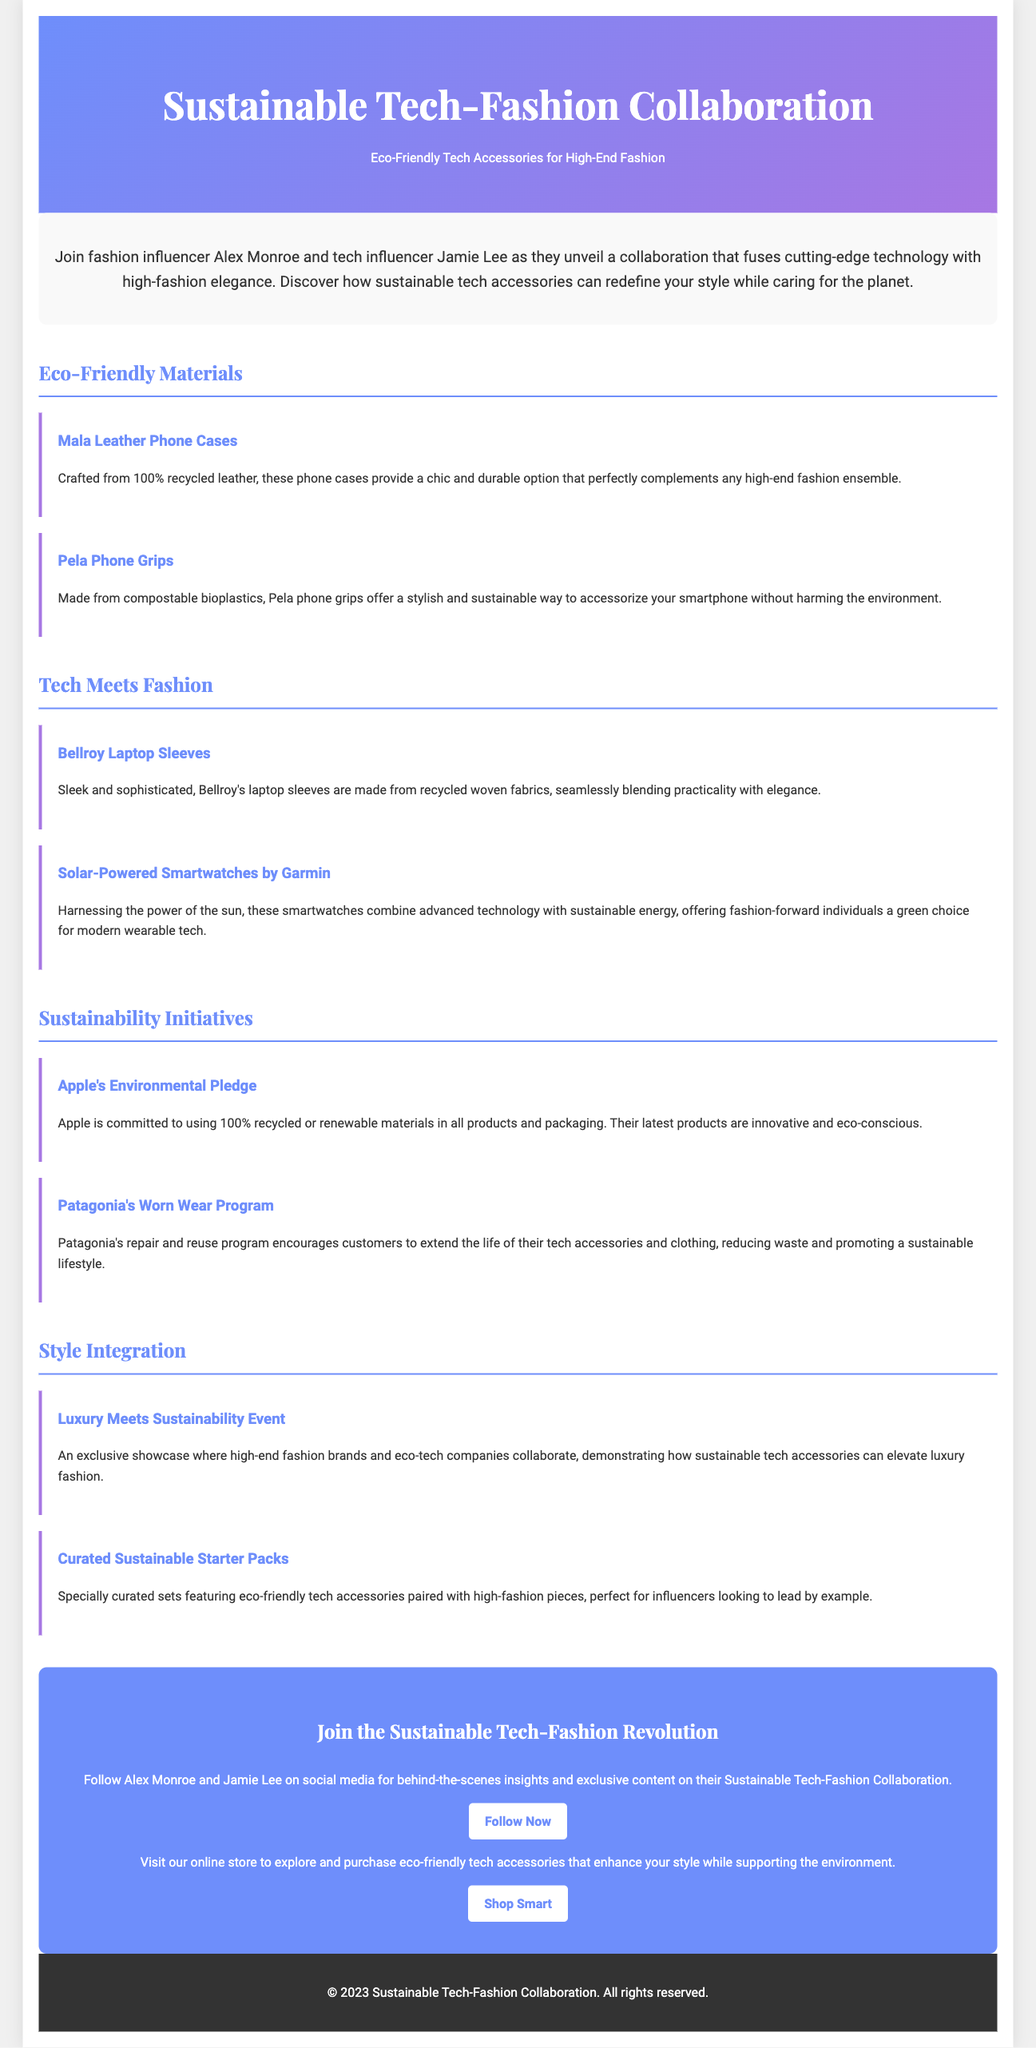What are the names of the collaborating influencers? The document mentions Alex Monroe and Jamie Lee as the collaborating influencers.
Answer: Alex Monroe and Jamie Lee What material are the Mala Leather Phone Cases made of? The document states that Mala Leather Phone Cases are crafted from 100% recycled leather.
Answer: 100% recycled leather What type of plastics are Pela Phone Grips made from? The document specifies that Pela Phone Grips are made from compostable bioplastics.
Answer: Compostable bioplastics Which brand offers solar-powered smartwatches? The document identifies Garmin as the brand that offers solar-powered smartwatches.
Answer: Garmin What is Patagonia's Worn Wear Program about? The document describes Patagonia's Worn Wear Program as a repair and reuse program that encourages extending the life of tech accessories and clothing.
Answer: Repair and reuse program What event showcases the integration of luxury fashion and eco-tech companies? The document refers to an exclusive showcase called the "Luxury Meets Sustainability Event."
Answer: Luxury Meets Sustainability Event How can followers engage with the influencers on social media? The document suggests following Alex Monroe and Jamie Lee on social media for exclusive content.
Answer: Follow on social media What is the call to action regarding the online store? The document invites readers to visit the online store to explore and purchase eco-friendly tech accessories.
Answer: Explore and purchase eco-friendly tech accessories 